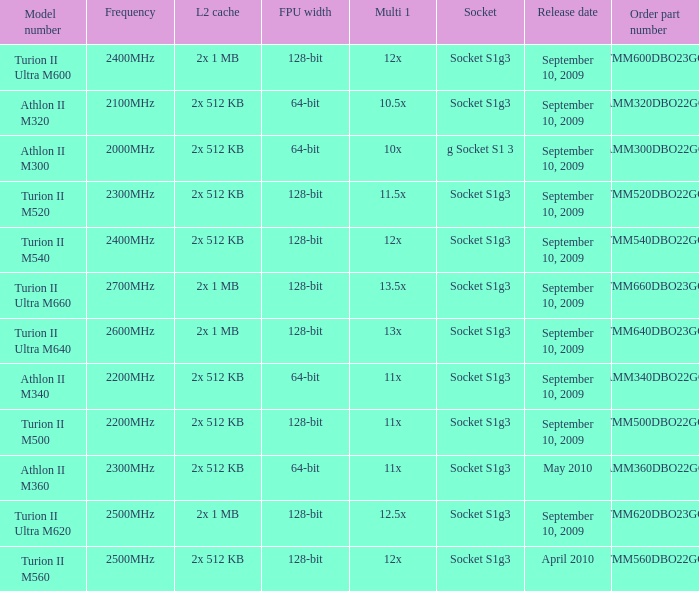What is the L2 cache with a 13.5x multi 1? 2x 1 MB. 